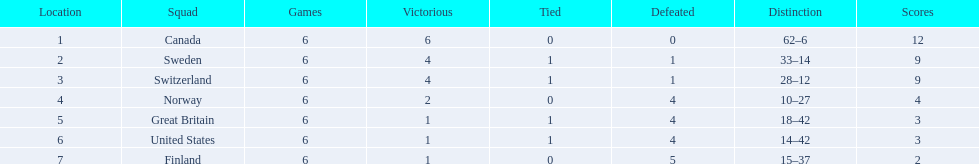What are all the teams? Canada, Sweden, Switzerland, Norway, Great Britain, United States, Finland. What were their points? 12, 9, 9, 4, 3, 3, 2. What about just switzerland and great britain? 9, 3. Now, which of those teams scored higher? Switzerland. 